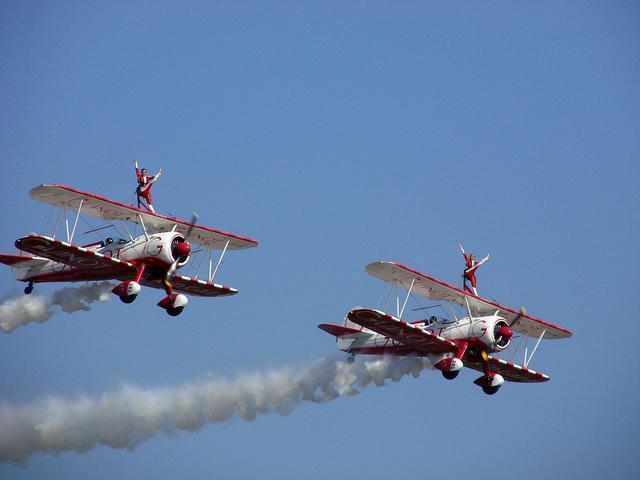How many aircrafts are flying?
Give a very brief answer. 2. How many airplanes are there?
Give a very brief answer. 2. How many cows are standing up?
Give a very brief answer. 0. 